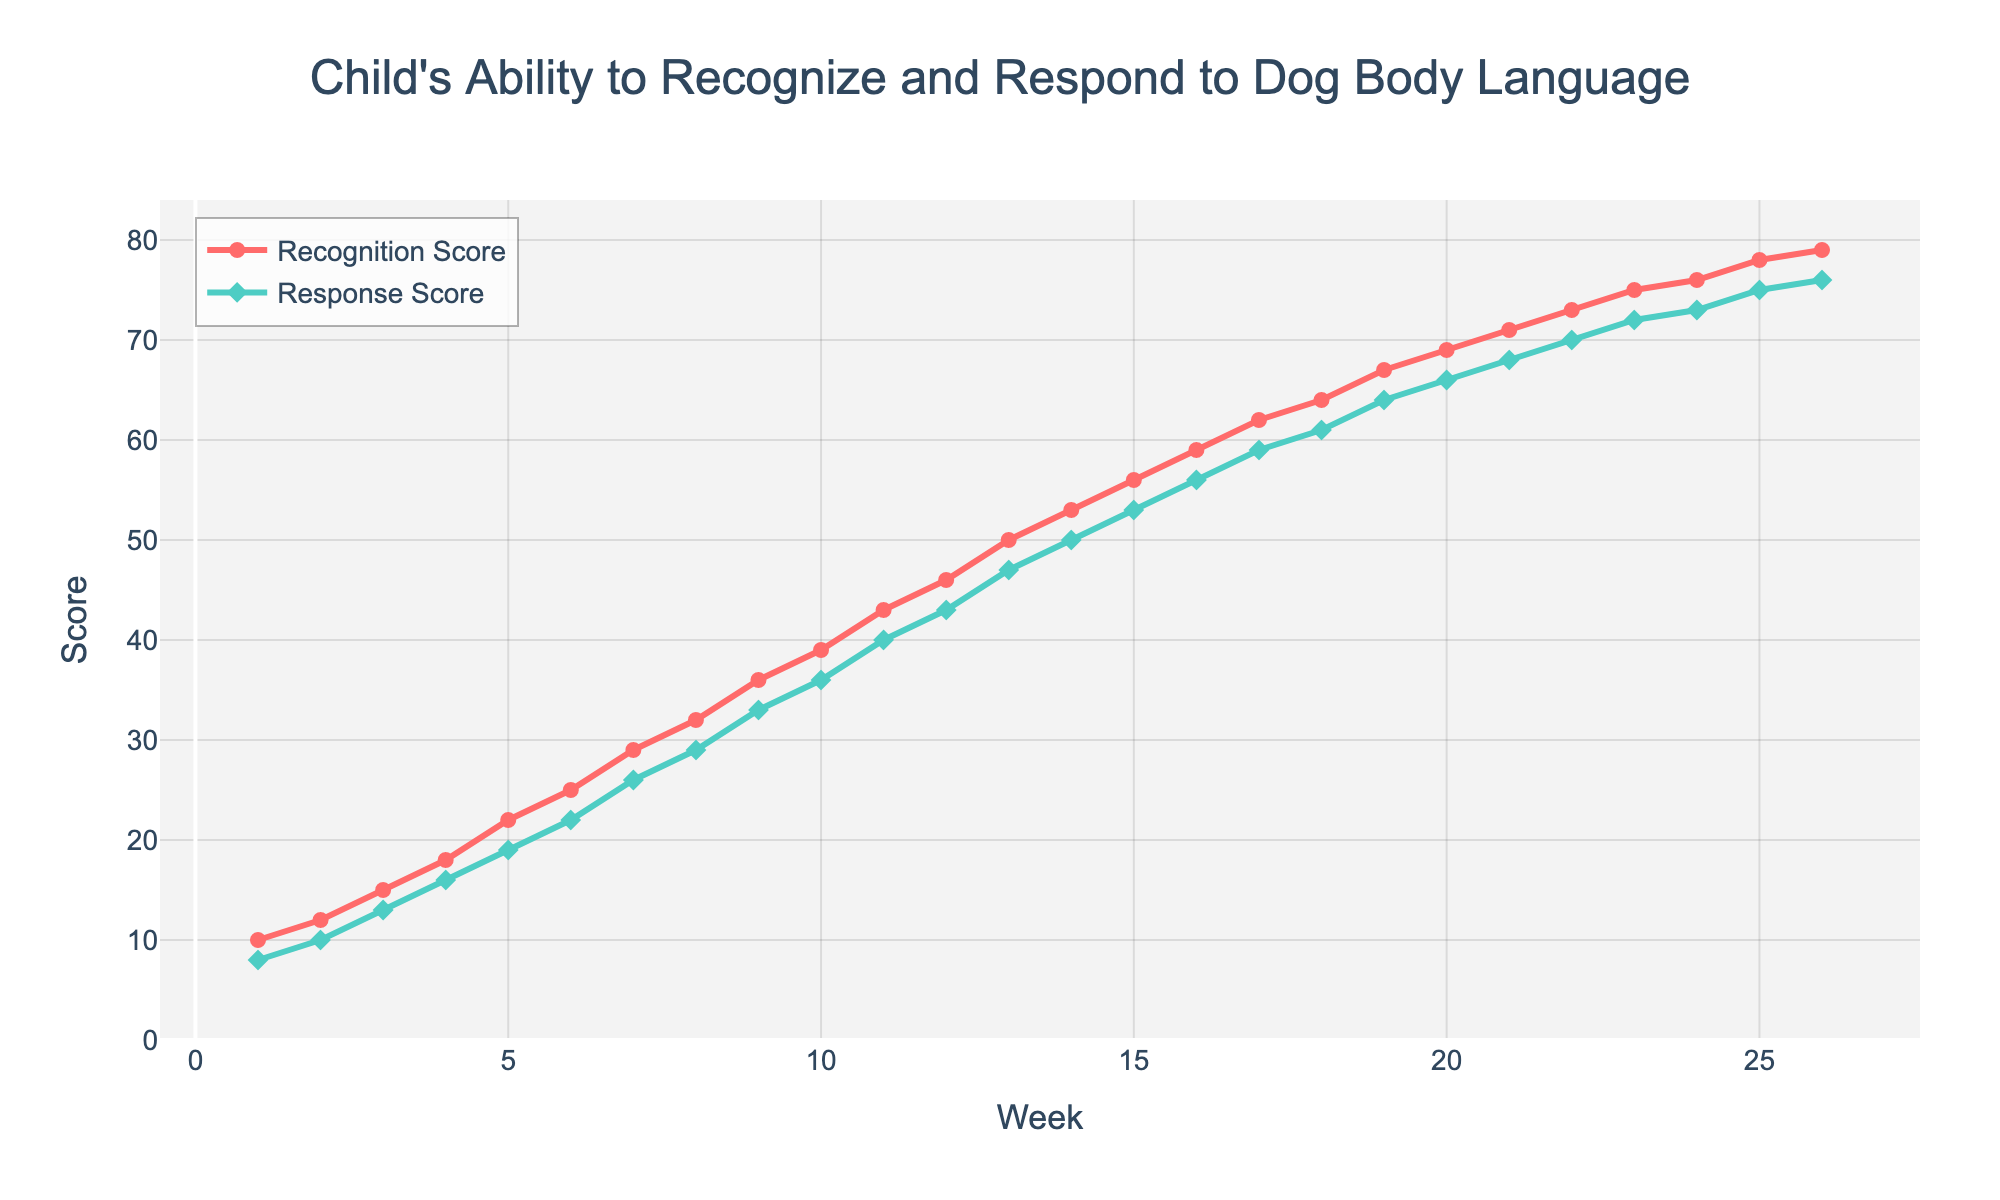What are the recognition and response scores at Week 10? At Week 10, the y-values for the Recognition Score (red line) and Response Score (green line) indicate the scores. The Recognition Score is 39 and the Response Score is 36.
Answer: Recognition Score: 39, Response Score: 36 How much did the response score increase from Week 1 to Week 26? To find the increase, subtract the Week 1 Response Score from the Week 26 Response Score. Week 1 Response Score is 8, and Week 26 Response Score is 76. The increase is 76 - 8 = 68.
Answer: 68 Between which weeks did the recognition score increase by 10 the fastest? Look at the slope of the red line and find the steepest section. From Week 1 to Week 2, the score increases from 10 to 12, and from Week 2 to Week 3, it increases from 12 to 15. The steepest increase by 10 is from Week 14 to Week 16, from 53 to 59 and then from 59 to 62.
Answer: Week 14 to Week 16 What is the difference between the recognition and response scores at Week 20? At Week 20, the Recognition Score is 69, and the Response Score is 66. The difference is 69 - 66 = 3.
Answer: 3 Which week shows the highest scores for both recognition and response? Check the end of the lines for both the red and green lines. Week 26 has the highest scores: Recognition Score is 79, Response Score is 76.
Answer: Week 26 On which weeks are the recognition and response scores equal? Look along the x-axis and find when the red and green lines intersect. The scores start close to each other but do not intersect, meaning they are never equal in this range of data.
Answer: None What is the average recognition score over 26 weeks? Sum all the recognition scores from Week 1 to Week 26 and divide by 26. Total sum is (10 + 12 + ... + 79) = 1060. The average is 1060/26 ≈ 40.77.
Answer: ~40.77 Compare the trend of response scores from Week 5 to Week 10 with Week 20 to Week 25. Which period shows a steeper increase? Compute the slope for both periods by calculating the rate of change per week. Week 5 to 10: from 19 to 36 (17 units over 5 weeks, 17/5 = 3.4 units/week), Week 20 to 25: from 66 to 75 (9 units over 5 weeks, 9/5 = 1.8 units/week).
Answer: Week 5 to Week 10 In Week 10, by how much does the recognition score exceed the response score? Week 10's Recognition Score is 39, and Response Score is 36. The difference is 39 - 36 = 3.
Answer: 3 What is the median response score? Arrange the response scores in ascending order and find the middle value. For 26 weeks, the median is the average of the 13th and 14th scores: (47 + 50)/2 = 48.5.
Answer: 48.5 